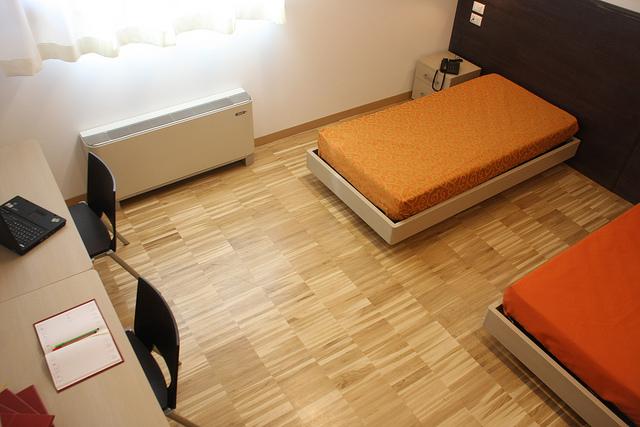What is the name of the hotel?
Give a very brief answer. Marriott. What time of day is it?
Give a very brief answer. Morning. What room is this?
Keep it brief. Bedroom. How many beds?
Short answer required. 2. 